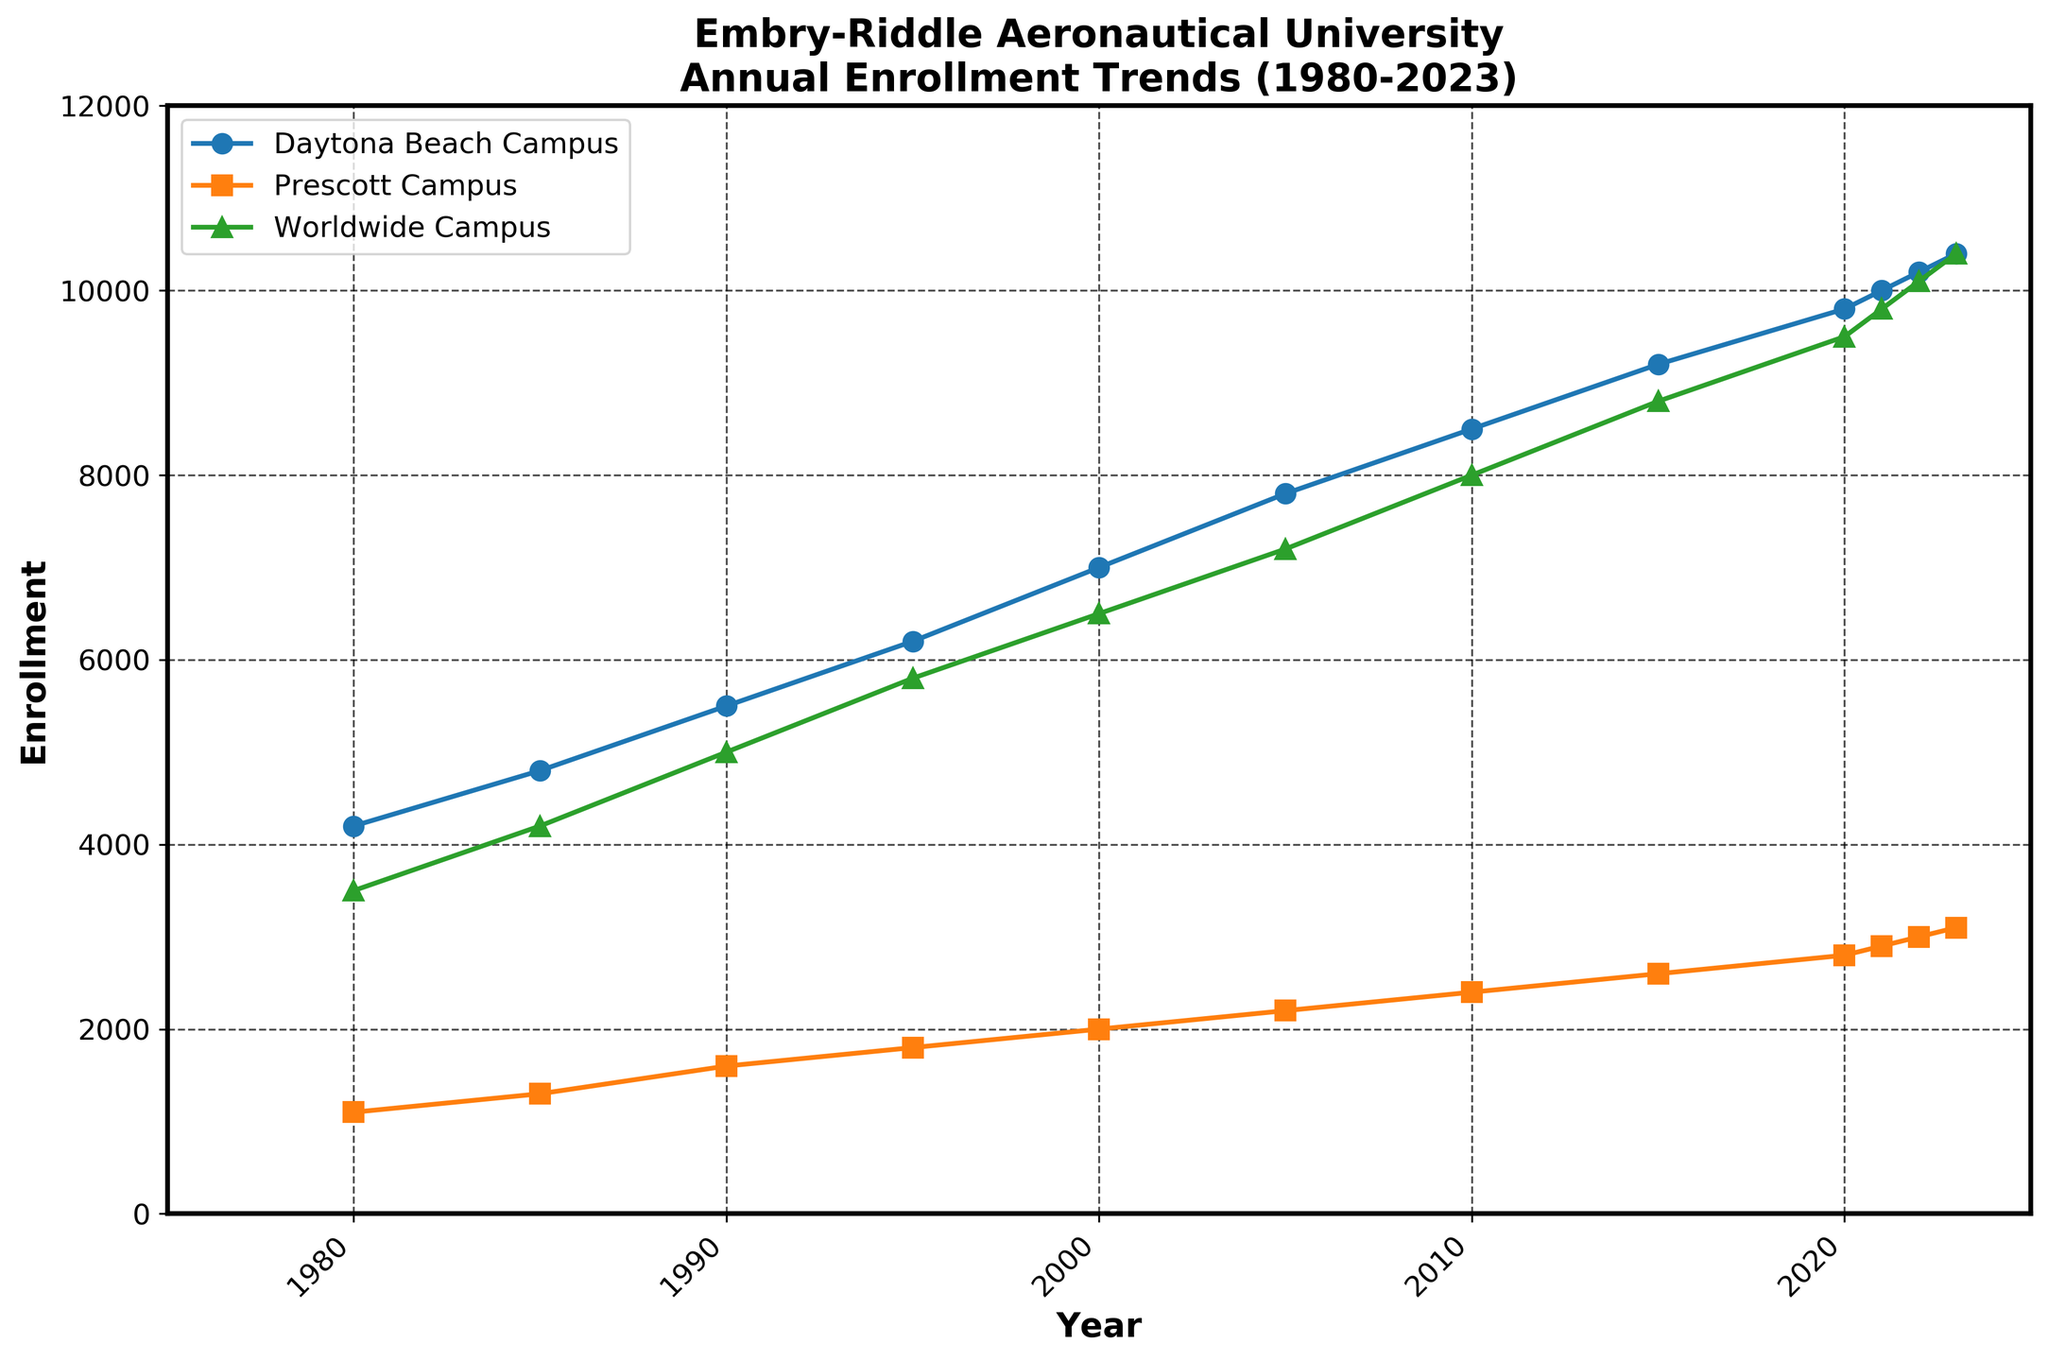What is the total enrollment in 2005? Locate 2005 on the x-axis and find the corresponding y-values for Daytona Beach Campus, Prescott Campus, and Worldwide Campus. Sum these values: 7800 + 2200 + 7200 = 17200.
Answer: 17200 Which campus had the highest enrollment in 2023? Find the 2023 values for Daytona Beach Campus, Prescott Campus, and Worldwide Campus. The values are 10400, 3100, and 10400, respectively. The Daytona Beach and Worldwide Campuses both have the highest enrollment with 10400 each.
Answer: Daytona Beach and Worldwide Campus How has the enrollment at the Daytona Beach Campus changed from 1980 to 2023? Note the enrollment numbers for Daytona Beach in 1980 and 2023 from the data: 4200 in 1980 and 10400 in 2023. Calculate the difference: 10400 - 4200 = 6200.
Answer: Increased by 6200 Between which two consecutive years did the Prescott Campus see the largest increase in enrollment? Compare the differences between consecutive years for Prescott Campus: 
1980-1985: 1300 - 1100 = 200 
1985-1990: 1600 - 1300 = 300 
1990-1995: 1800 - 1600 = 200 
1995-2000: 2000 - 1800 = 200 
2000-2005: 2200 - 2000 = 200 
2005-2010: 2400 - 2200 = 200 
2010-2015: 2600 - 2400 = 200 
2015-2020: 2800 - 2600 = 200 
2020-2021: 2900 - 2800 = 100 
2021-2022: 3000 - 2900 = 100 
2022-2023: 3100 - 3000 = 100. 
The largest increase occurred between 1985 and 1990 with an increase of 300.
Answer: 1985 and 1990 In which year did the Worldwide Campus first exceed 9000 enrollments? Locate the y-values for the Worldwide Campus across the years and identify the first year where their value exceeds 9000. This happens in 2015.
Answer: 2015 What is the average enrollment at Worldwide Campus from 2010 to 2020? Consider the enrollment numbers for Worldwide Campus for 2010, 2015, and 2020: 8000, 8800, and 9500. Calculate the average: (8000 + 8800 + 9500)/3 = 26300/3 ≈ 8767.
Answer: 8767 Compare the total enrollment growth between 1980 and 2023 for Daytona Beach Campus and Prescott Campus. Which campus had a greater increase? For Daytona Beach: 10400 - 4200 = 6200. For Prescott: 3100 - 1100 = 2000. Daytona Beach has a greater increase with 6200 compared to Prescott's 2000.
Answer: Daytona Beach Campus What is the trend in total enrollment from 1995 to 2023? Observe the total enrollment values from 1995 to 2023: 
1995: 13800 
2000: 15500 
2005: 17200 
2010: 18900 
2015: 20600 
2020: 22100 
2021: 22700 
2022: 23300 
2023: 23900. 
The numbers show a consistent increase over the years.
Answer: Consistent increase How does the enrollment in 2023 at Prescott Campus compare to Worldwide Campus? Find the enrollment values for 2023: Prescott Campus: 3100, Worldwide Campus: 10400. Compare the two values: 3100 < 10400.
Answer: Prescott Campus has less enrollment What is the total increase in enrollment for all campuses combined from 1980 to 2023? Calculate the difference in total enrollment between 1980 and 2023: 23900 - 8800 = 15100.
Answer: Increased by 15100 